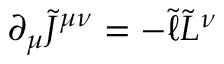Convert formula to latex. <formula><loc_0><loc_0><loc_500><loc_500>\partial _ { \mu } \tilde { J } ^ { \mu \nu } = - \tilde { \ell } \tilde { L } ^ { \nu }</formula> 